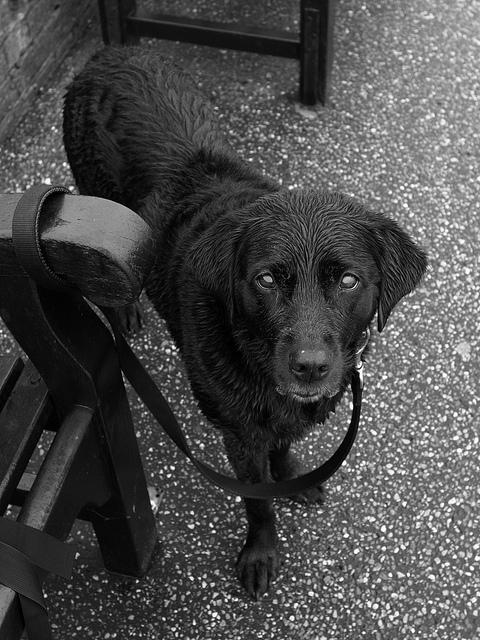Is the dog tied up?
Keep it brief. Yes. Are the dog's eyes open?
Give a very brief answer. Yes. What is around the dog's neck?
Write a very short answer. Leash. What color is the dog's leash?
Keep it brief. Black. Is the dog standing up?
Keep it brief. Yes. 